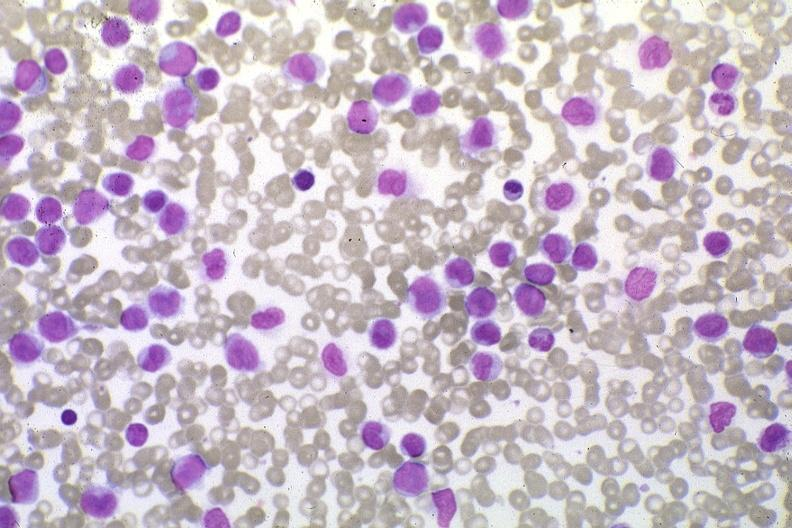s macerated stillborn present?
Answer the question using a single word or phrase. No 